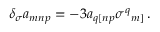Convert formula to latex. <formula><loc_0><loc_0><loc_500><loc_500>\delta _ { \sigma } a _ { m n p } = - 3 a _ { q [ n p } \sigma ^ { q _ { m ] } \, .</formula> 